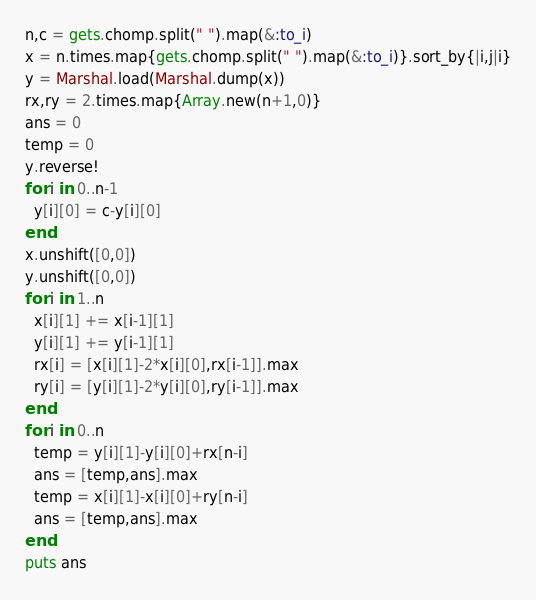<code> <loc_0><loc_0><loc_500><loc_500><_Ruby_>n,c = gets.chomp.split(" ").map(&:to_i)
x = n.times.map{gets.chomp.split(" ").map(&:to_i)}.sort_by{|i,j|i}
y = Marshal.load(Marshal.dump(x))
rx,ry = 2.times.map{Array.new(n+1,0)}
ans = 0
temp = 0
y.reverse!
for i in 0..n-1
  y[i][0] = c-y[i][0]
end
x.unshift([0,0])
y.unshift([0,0])
for i in 1..n
  x[i][1] += x[i-1][1]
  y[i][1] += y[i-1][1]
  rx[i] = [x[i][1]-2*x[i][0],rx[i-1]].max
  ry[i] = [y[i][1]-2*y[i][0],ry[i-1]].max
end
for i in 0..n
  temp = y[i][1]-y[i][0]+rx[n-i]
  ans = [temp,ans].max
  temp = x[i][1]-x[i][0]+ry[n-i]
  ans = [temp,ans].max
end
puts ans</code> 